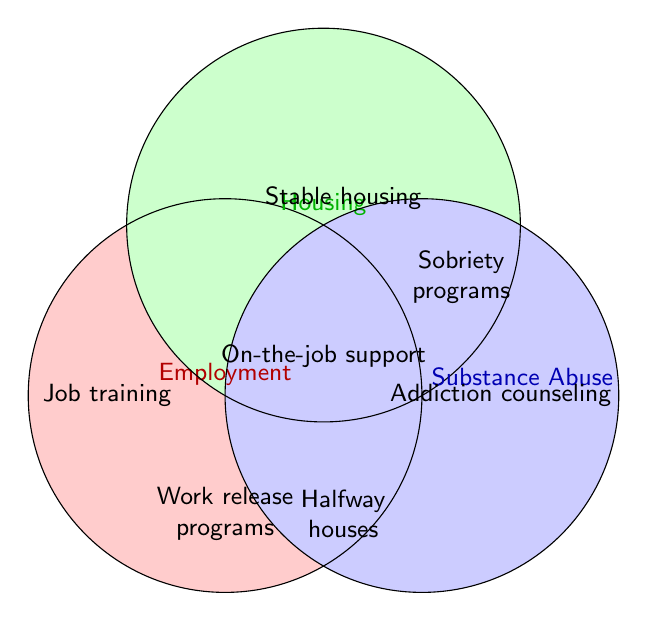What three aspects are covered in the Venn Diagram? The Venn Diagram includes three intersecting circles, each labeled with a specific factor. By looking at the labels, these factors are Employment, Housing, and Substance Abuse.
Answer: Employment, Housing, and Substance Abuse Which section represents people with stable housing? The section labeled "Stable housing" is inside the green circle, visually identified as the segment named Housing.
Answer: Stable housing How does 'Work release programs' relate to the diagram's categories? 'Work release programs' is located inside the overlap area between the Employment and Substance Abuse categories, indicating it involves both.
Answer: Employment and Substance Abuse What is located at the intersection of Employment and Housing categories? The intersection of Employment and Housing does not label any specific program in this diagram.
Answer: None Which areas are represented by the 'Addiction counseling'? 'Addiction counseling' is entirely within the blue circle labeled Substance Abuse, indicating it's related only to Substance Abuse.
Answer: Substance Abuse Are there any areas representing 'Relapse prevention'? The diagram does not show 'Relapse prevention'; it is part of the provided data but not the figure.
Answer: None Compare the placement of 'On-the-job support' and 'Employer partnerships'. 'On-the-job support' is used in the intersection of multiple categories, while 'Employer partnerships' is not visually represented in the intersections. Only 'On-the-job support' is displayed in the Venn Diagram.
Answer: On-the-job support: Yes, Employer partnerships: No Which section includes 'Halfway houses'? 'Halfway houses' is shown inside the composite area of Housing and Substance Abuse, suggesting involvement in both.
Answer: Housing and Substance Abuse Identify the exclusive area for Employment. The exclusive area for Employment has 'Job training' and 'Work release programs'. 'Job training' is solely in Employment but 'Work release programs' also marks an overlap.
Answer: Job training Locate which categories 'Addiction counseling' overlaps. 'Addiction counseling' lies solely within the Substance Abuse circle but no overlap with Employment or Housing.
Answer: Substance Abuse only 